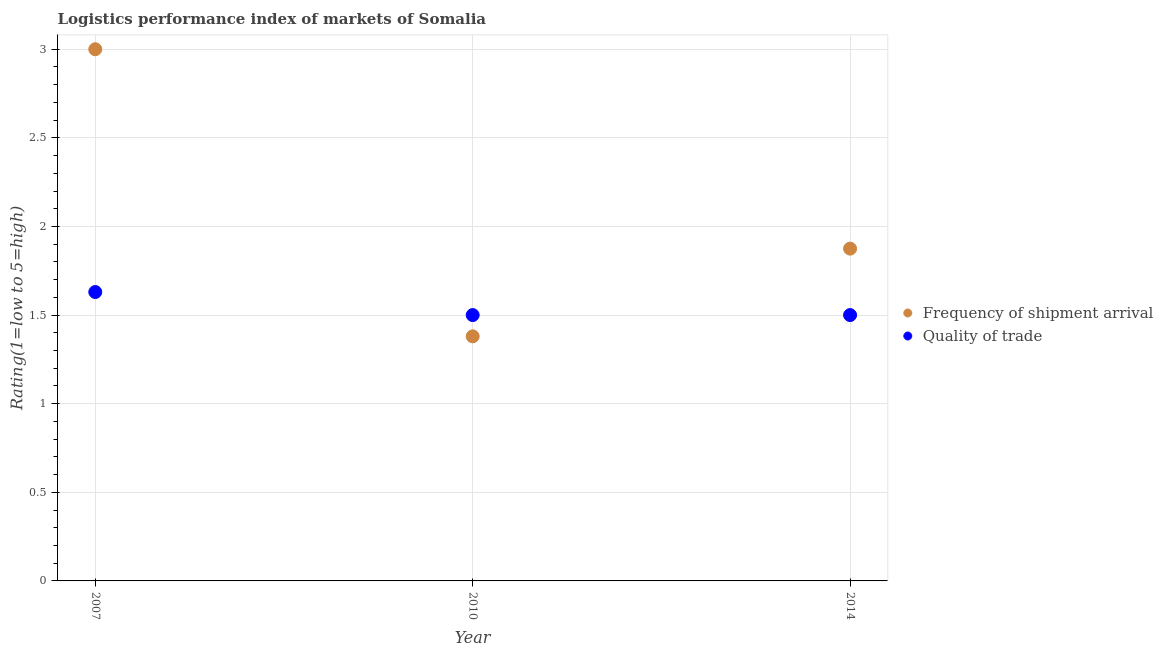How many different coloured dotlines are there?
Ensure brevity in your answer.  2. Across all years, what is the minimum lpi quality of trade?
Give a very brief answer. 1.5. What is the total lpi quality of trade in the graph?
Ensure brevity in your answer.  4.63. What is the difference between the lpi of frequency of shipment arrival in 2007 and that in 2014?
Ensure brevity in your answer.  1.12. What is the difference between the lpi of frequency of shipment arrival in 2007 and the lpi quality of trade in 2014?
Make the answer very short. 1.5. What is the average lpi of frequency of shipment arrival per year?
Provide a succinct answer. 2.08. In the year 2014, what is the difference between the lpi quality of trade and lpi of frequency of shipment arrival?
Your response must be concise. -0.38. What is the ratio of the lpi quality of trade in 2010 to that in 2014?
Your answer should be very brief. 1. Is the difference between the lpi of frequency of shipment arrival in 2007 and 2014 greater than the difference between the lpi quality of trade in 2007 and 2014?
Ensure brevity in your answer.  Yes. What is the difference between the highest and the second highest lpi of frequency of shipment arrival?
Give a very brief answer. 1.12. What is the difference between the highest and the lowest lpi quality of trade?
Your response must be concise. 0.13. Is the sum of the lpi of frequency of shipment arrival in 2007 and 2010 greater than the maximum lpi quality of trade across all years?
Give a very brief answer. Yes. Does the lpi of frequency of shipment arrival monotonically increase over the years?
Make the answer very short. No. Is the lpi of frequency of shipment arrival strictly greater than the lpi quality of trade over the years?
Your answer should be very brief. No. Does the graph contain any zero values?
Offer a terse response. No. Does the graph contain grids?
Offer a very short reply. Yes. How many legend labels are there?
Your answer should be very brief. 2. How are the legend labels stacked?
Ensure brevity in your answer.  Vertical. What is the title of the graph?
Ensure brevity in your answer.  Logistics performance index of markets of Somalia. What is the label or title of the Y-axis?
Your response must be concise. Rating(1=low to 5=high). What is the Rating(1=low to 5=high) in Frequency of shipment arrival in 2007?
Make the answer very short. 3. What is the Rating(1=low to 5=high) of Quality of trade in 2007?
Offer a terse response. 1.63. What is the Rating(1=low to 5=high) of Frequency of shipment arrival in 2010?
Your answer should be very brief. 1.38. What is the Rating(1=low to 5=high) in Frequency of shipment arrival in 2014?
Ensure brevity in your answer.  1.88. What is the Rating(1=low to 5=high) in Quality of trade in 2014?
Give a very brief answer. 1.5. Across all years, what is the maximum Rating(1=low to 5=high) in Frequency of shipment arrival?
Ensure brevity in your answer.  3. Across all years, what is the maximum Rating(1=low to 5=high) in Quality of trade?
Provide a succinct answer. 1.63. Across all years, what is the minimum Rating(1=low to 5=high) of Frequency of shipment arrival?
Offer a very short reply. 1.38. Across all years, what is the minimum Rating(1=low to 5=high) in Quality of trade?
Offer a terse response. 1.5. What is the total Rating(1=low to 5=high) in Frequency of shipment arrival in the graph?
Ensure brevity in your answer.  6.25. What is the total Rating(1=low to 5=high) in Quality of trade in the graph?
Your answer should be very brief. 4.63. What is the difference between the Rating(1=low to 5=high) in Frequency of shipment arrival in 2007 and that in 2010?
Provide a short and direct response. 1.62. What is the difference between the Rating(1=low to 5=high) of Quality of trade in 2007 and that in 2010?
Your answer should be compact. 0.13. What is the difference between the Rating(1=low to 5=high) of Quality of trade in 2007 and that in 2014?
Keep it short and to the point. 0.13. What is the difference between the Rating(1=low to 5=high) of Frequency of shipment arrival in 2010 and that in 2014?
Your answer should be compact. -0.49. What is the difference between the Rating(1=low to 5=high) of Frequency of shipment arrival in 2010 and the Rating(1=low to 5=high) of Quality of trade in 2014?
Your response must be concise. -0.12. What is the average Rating(1=low to 5=high) in Frequency of shipment arrival per year?
Ensure brevity in your answer.  2.08. What is the average Rating(1=low to 5=high) of Quality of trade per year?
Keep it short and to the point. 1.54. In the year 2007, what is the difference between the Rating(1=low to 5=high) of Frequency of shipment arrival and Rating(1=low to 5=high) of Quality of trade?
Ensure brevity in your answer.  1.37. In the year 2010, what is the difference between the Rating(1=low to 5=high) of Frequency of shipment arrival and Rating(1=low to 5=high) of Quality of trade?
Your answer should be compact. -0.12. What is the ratio of the Rating(1=low to 5=high) of Frequency of shipment arrival in 2007 to that in 2010?
Provide a succinct answer. 2.17. What is the ratio of the Rating(1=low to 5=high) in Quality of trade in 2007 to that in 2010?
Offer a terse response. 1.09. What is the ratio of the Rating(1=low to 5=high) of Quality of trade in 2007 to that in 2014?
Your response must be concise. 1.09. What is the ratio of the Rating(1=low to 5=high) in Frequency of shipment arrival in 2010 to that in 2014?
Your response must be concise. 0.74. What is the ratio of the Rating(1=low to 5=high) in Quality of trade in 2010 to that in 2014?
Keep it short and to the point. 1. What is the difference between the highest and the second highest Rating(1=low to 5=high) of Frequency of shipment arrival?
Your answer should be compact. 1.12. What is the difference between the highest and the second highest Rating(1=low to 5=high) in Quality of trade?
Offer a very short reply. 0.13. What is the difference between the highest and the lowest Rating(1=low to 5=high) of Frequency of shipment arrival?
Make the answer very short. 1.62. What is the difference between the highest and the lowest Rating(1=low to 5=high) in Quality of trade?
Your response must be concise. 0.13. 